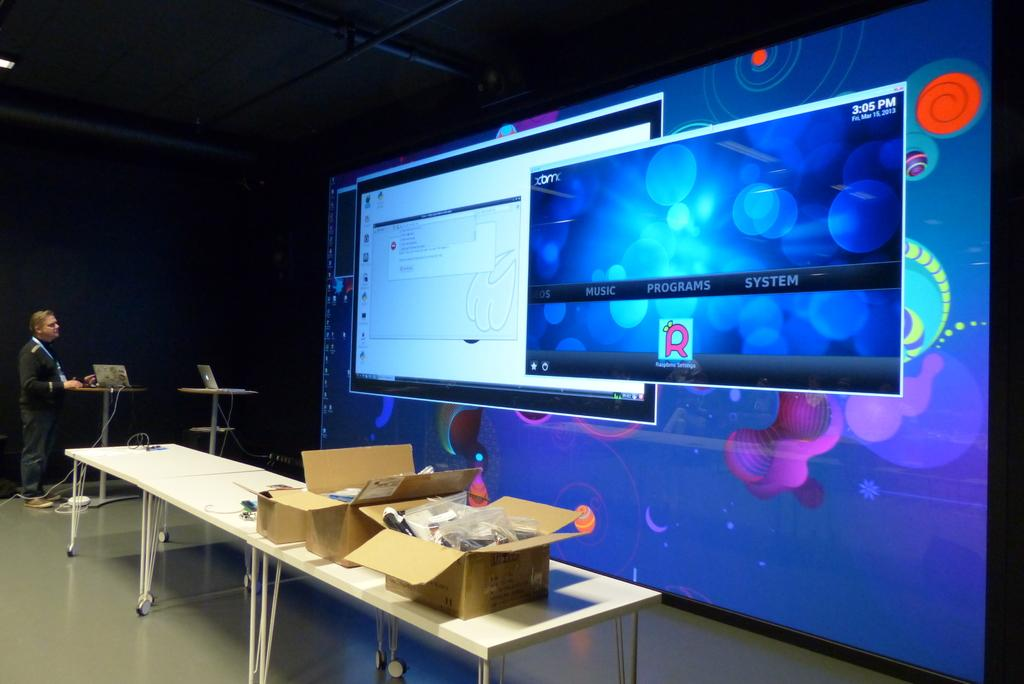<image>
Give a short and clear explanation of the subsequent image. A man at a table is looking at a large digital display where one of the windows on the display is showing the time as 3:05 pm. 